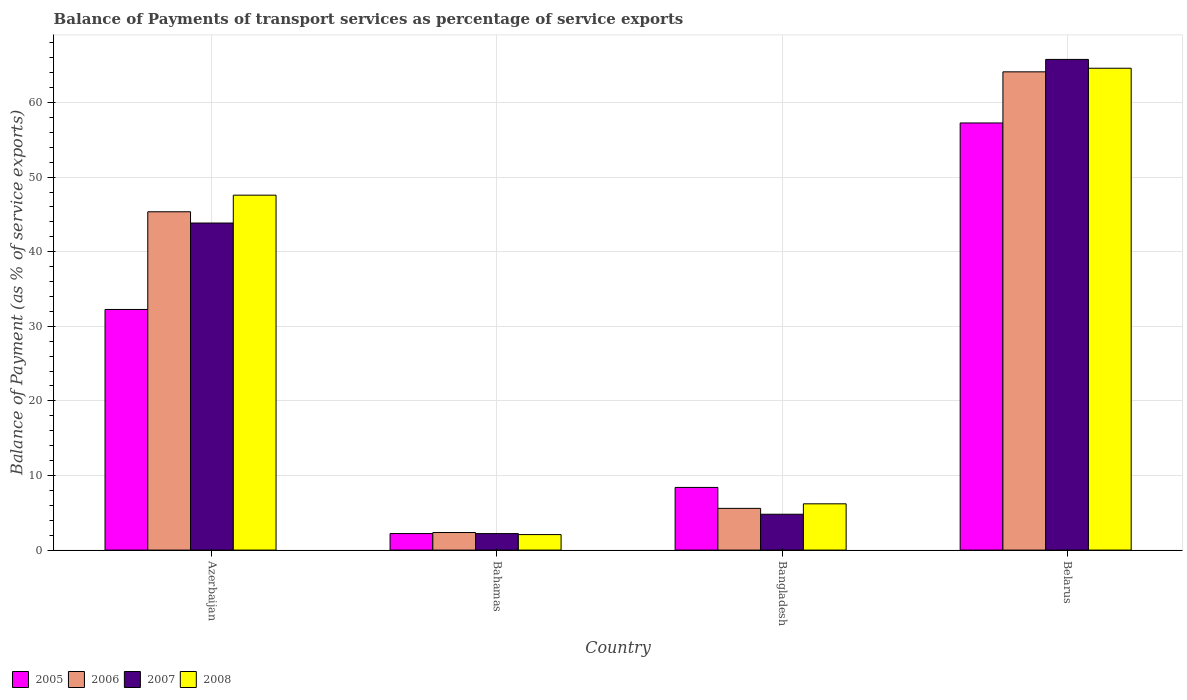How many groups of bars are there?
Offer a terse response. 4. Are the number of bars on each tick of the X-axis equal?
Make the answer very short. Yes. What is the label of the 4th group of bars from the left?
Offer a terse response. Belarus. What is the balance of payments of transport services in 2007 in Bahamas?
Provide a succinct answer. 2.21. Across all countries, what is the maximum balance of payments of transport services in 2006?
Your answer should be very brief. 64.11. Across all countries, what is the minimum balance of payments of transport services in 2008?
Your answer should be compact. 2.08. In which country was the balance of payments of transport services in 2008 maximum?
Offer a terse response. Belarus. In which country was the balance of payments of transport services in 2008 minimum?
Make the answer very short. Bahamas. What is the total balance of payments of transport services in 2005 in the graph?
Give a very brief answer. 100.14. What is the difference between the balance of payments of transport services in 2008 in Azerbaijan and that in Bangladesh?
Provide a succinct answer. 41.38. What is the difference between the balance of payments of transport services in 2008 in Belarus and the balance of payments of transport services in 2006 in Bahamas?
Offer a very short reply. 62.24. What is the average balance of payments of transport services in 2008 per country?
Make the answer very short. 30.12. What is the difference between the balance of payments of transport services of/in 2006 and balance of payments of transport services of/in 2007 in Bangladesh?
Provide a short and direct response. 0.79. In how many countries, is the balance of payments of transport services in 2007 greater than 22 %?
Make the answer very short. 2. What is the ratio of the balance of payments of transport services in 2008 in Azerbaijan to that in Belarus?
Provide a succinct answer. 0.74. Is the balance of payments of transport services in 2008 in Bahamas less than that in Belarus?
Give a very brief answer. Yes. What is the difference between the highest and the second highest balance of payments of transport services in 2005?
Provide a short and direct response. -25. What is the difference between the highest and the lowest balance of payments of transport services in 2007?
Make the answer very short. 63.57. Is it the case that in every country, the sum of the balance of payments of transport services in 2005 and balance of payments of transport services in 2006 is greater than the sum of balance of payments of transport services in 2008 and balance of payments of transport services in 2007?
Provide a succinct answer. No. Is it the case that in every country, the sum of the balance of payments of transport services in 2007 and balance of payments of transport services in 2008 is greater than the balance of payments of transport services in 2005?
Your answer should be very brief. Yes. How many bars are there?
Provide a short and direct response. 16. How many countries are there in the graph?
Your answer should be very brief. 4. What is the difference between two consecutive major ticks on the Y-axis?
Offer a very short reply. 10. Are the values on the major ticks of Y-axis written in scientific E-notation?
Provide a succinct answer. No. Does the graph contain any zero values?
Keep it short and to the point. No. Does the graph contain grids?
Ensure brevity in your answer.  Yes. Where does the legend appear in the graph?
Offer a terse response. Bottom left. How many legend labels are there?
Your answer should be compact. 4. What is the title of the graph?
Provide a succinct answer. Balance of Payments of transport services as percentage of service exports. What is the label or title of the Y-axis?
Offer a terse response. Balance of Payment (as % of service exports). What is the Balance of Payment (as % of service exports) of 2005 in Azerbaijan?
Offer a terse response. 32.26. What is the Balance of Payment (as % of service exports) of 2006 in Azerbaijan?
Keep it short and to the point. 45.35. What is the Balance of Payment (as % of service exports) of 2007 in Azerbaijan?
Provide a short and direct response. 43.85. What is the Balance of Payment (as % of service exports) in 2008 in Azerbaijan?
Provide a succinct answer. 47.58. What is the Balance of Payment (as % of service exports) of 2005 in Bahamas?
Your response must be concise. 2.22. What is the Balance of Payment (as % of service exports) of 2006 in Bahamas?
Offer a very short reply. 2.36. What is the Balance of Payment (as % of service exports) of 2007 in Bahamas?
Ensure brevity in your answer.  2.21. What is the Balance of Payment (as % of service exports) of 2008 in Bahamas?
Provide a succinct answer. 2.08. What is the Balance of Payment (as % of service exports) of 2005 in Bangladesh?
Ensure brevity in your answer.  8.4. What is the Balance of Payment (as % of service exports) in 2006 in Bangladesh?
Offer a terse response. 5.6. What is the Balance of Payment (as % of service exports) in 2007 in Bangladesh?
Keep it short and to the point. 4.81. What is the Balance of Payment (as % of service exports) in 2008 in Bangladesh?
Provide a short and direct response. 6.21. What is the Balance of Payment (as % of service exports) in 2005 in Belarus?
Your answer should be compact. 57.26. What is the Balance of Payment (as % of service exports) in 2006 in Belarus?
Keep it short and to the point. 64.11. What is the Balance of Payment (as % of service exports) in 2007 in Belarus?
Provide a succinct answer. 65.78. What is the Balance of Payment (as % of service exports) of 2008 in Belarus?
Offer a very short reply. 64.6. Across all countries, what is the maximum Balance of Payment (as % of service exports) of 2005?
Keep it short and to the point. 57.26. Across all countries, what is the maximum Balance of Payment (as % of service exports) of 2006?
Keep it short and to the point. 64.11. Across all countries, what is the maximum Balance of Payment (as % of service exports) of 2007?
Offer a terse response. 65.78. Across all countries, what is the maximum Balance of Payment (as % of service exports) in 2008?
Ensure brevity in your answer.  64.6. Across all countries, what is the minimum Balance of Payment (as % of service exports) of 2005?
Your answer should be very brief. 2.22. Across all countries, what is the minimum Balance of Payment (as % of service exports) of 2006?
Give a very brief answer. 2.36. Across all countries, what is the minimum Balance of Payment (as % of service exports) in 2007?
Offer a terse response. 2.21. Across all countries, what is the minimum Balance of Payment (as % of service exports) of 2008?
Give a very brief answer. 2.08. What is the total Balance of Payment (as % of service exports) of 2005 in the graph?
Offer a terse response. 100.14. What is the total Balance of Payment (as % of service exports) in 2006 in the graph?
Your answer should be very brief. 117.42. What is the total Balance of Payment (as % of service exports) of 2007 in the graph?
Offer a terse response. 116.65. What is the total Balance of Payment (as % of service exports) of 2008 in the graph?
Make the answer very short. 120.46. What is the difference between the Balance of Payment (as % of service exports) in 2005 in Azerbaijan and that in Bahamas?
Provide a succinct answer. 30.04. What is the difference between the Balance of Payment (as % of service exports) in 2006 in Azerbaijan and that in Bahamas?
Make the answer very short. 43. What is the difference between the Balance of Payment (as % of service exports) in 2007 in Azerbaijan and that in Bahamas?
Your answer should be compact. 41.63. What is the difference between the Balance of Payment (as % of service exports) in 2008 in Azerbaijan and that in Bahamas?
Your answer should be compact. 45.5. What is the difference between the Balance of Payment (as % of service exports) of 2005 in Azerbaijan and that in Bangladesh?
Keep it short and to the point. 23.86. What is the difference between the Balance of Payment (as % of service exports) in 2006 in Azerbaijan and that in Bangladesh?
Offer a terse response. 39.76. What is the difference between the Balance of Payment (as % of service exports) of 2007 in Azerbaijan and that in Bangladesh?
Give a very brief answer. 39.04. What is the difference between the Balance of Payment (as % of service exports) in 2008 in Azerbaijan and that in Bangladesh?
Give a very brief answer. 41.38. What is the difference between the Balance of Payment (as % of service exports) of 2005 in Azerbaijan and that in Belarus?
Give a very brief answer. -25. What is the difference between the Balance of Payment (as % of service exports) in 2006 in Azerbaijan and that in Belarus?
Ensure brevity in your answer.  -18.76. What is the difference between the Balance of Payment (as % of service exports) of 2007 in Azerbaijan and that in Belarus?
Make the answer very short. -21.93. What is the difference between the Balance of Payment (as % of service exports) in 2008 in Azerbaijan and that in Belarus?
Provide a short and direct response. -17.01. What is the difference between the Balance of Payment (as % of service exports) of 2005 in Bahamas and that in Bangladesh?
Your answer should be very brief. -6.18. What is the difference between the Balance of Payment (as % of service exports) of 2006 in Bahamas and that in Bangladesh?
Your answer should be compact. -3.24. What is the difference between the Balance of Payment (as % of service exports) of 2007 in Bahamas and that in Bangladesh?
Your answer should be very brief. -2.59. What is the difference between the Balance of Payment (as % of service exports) of 2008 in Bahamas and that in Bangladesh?
Keep it short and to the point. -4.12. What is the difference between the Balance of Payment (as % of service exports) of 2005 in Bahamas and that in Belarus?
Offer a terse response. -55.04. What is the difference between the Balance of Payment (as % of service exports) of 2006 in Bahamas and that in Belarus?
Provide a succinct answer. -61.76. What is the difference between the Balance of Payment (as % of service exports) of 2007 in Bahamas and that in Belarus?
Your answer should be compact. -63.57. What is the difference between the Balance of Payment (as % of service exports) in 2008 in Bahamas and that in Belarus?
Ensure brevity in your answer.  -62.51. What is the difference between the Balance of Payment (as % of service exports) in 2005 in Bangladesh and that in Belarus?
Provide a succinct answer. -48.86. What is the difference between the Balance of Payment (as % of service exports) in 2006 in Bangladesh and that in Belarus?
Provide a succinct answer. -58.52. What is the difference between the Balance of Payment (as % of service exports) of 2007 in Bangladesh and that in Belarus?
Ensure brevity in your answer.  -60.97. What is the difference between the Balance of Payment (as % of service exports) in 2008 in Bangladesh and that in Belarus?
Provide a succinct answer. -58.39. What is the difference between the Balance of Payment (as % of service exports) in 2005 in Azerbaijan and the Balance of Payment (as % of service exports) in 2006 in Bahamas?
Your response must be concise. 29.9. What is the difference between the Balance of Payment (as % of service exports) of 2005 in Azerbaijan and the Balance of Payment (as % of service exports) of 2007 in Bahamas?
Offer a terse response. 30.05. What is the difference between the Balance of Payment (as % of service exports) of 2005 in Azerbaijan and the Balance of Payment (as % of service exports) of 2008 in Bahamas?
Offer a very short reply. 30.18. What is the difference between the Balance of Payment (as % of service exports) of 2006 in Azerbaijan and the Balance of Payment (as % of service exports) of 2007 in Bahamas?
Your answer should be very brief. 43.14. What is the difference between the Balance of Payment (as % of service exports) in 2006 in Azerbaijan and the Balance of Payment (as % of service exports) in 2008 in Bahamas?
Give a very brief answer. 43.27. What is the difference between the Balance of Payment (as % of service exports) in 2007 in Azerbaijan and the Balance of Payment (as % of service exports) in 2008 in Bahamas?
Provide a succinct answer. 41.77. What is the difference between the Balance of Payment (as % of service exports) of 2005 in Azerbaijan and the Balance of Payment (as % of service exports) of 2006 in Bangladesh?
Your answer should be very brief. 26.66. What is the difference between the Balance of Payment (as % of service exports) of 2005 in Azerbaijan and the Balance of Payment (as % of service exports) of 2007 in Bangladesh?
Make the answer very short. 27.45. What is the difference between the Balance of Payment (as % of service exports) of 2005 in Azerbaijan and the Balance of Payment (as % of service exports) of 2008 in Bangladesh?
Give a very brief answer. 26.06. What is the difference between the Balance of Payment (as % of service exports) of 2006 in Azerbaijan and the Balance of Payment (as % of service exports) of 2007 in Bangladesh?
Provide a short and direct response. 40.55. What is the difference between the Balance of Payment (as % of service exports) in 2006 in Azerbaijan and the Balance of Payment (as % of service exports) in 2008 in Bangladesh?
Your response must be concise. 39.15. What is the difference between the Balance of Payment (as % of service exports) in 2007 in Azerbaijan and the Balance of Payment (as % of service exports) in 2008 in Bangladesh?
Your response must be concise. 37.64. What is the difference between the Balance of Payment (as % of service exports) in 2005 in Azerbaijan and the Balance of Payment (as % of service exports) in 2006 in Belarus?
Your response must be concise. -31.85. What is the difference between the Balance of Payment (as % of service exports) of 2005 in Azerbaijan and the Balance of Payment (as % of service exports) of 2007 in Belarus?
Your response must be concise. -33.52. What is the difference between the Balance of Payment (as % of service exports) in 2005 in Azerbaijan and the Balance of Payment (as % of service exports) in 2008 in Belarus?
Offer a terse response. -32.34. What is the difference between the Balance of Payment (as % of service exports) of 2006 in Azerbaijan and the Balance of Payment (as % of service exports) of 2007 in Belarus?
Provide a short and direct response. -20.43. What is the difference between the Balance of Payment (as % of service exports) in 2006 in Azerbaijan and the Balance of Payment (as % of service exports) in 2008 in Belarus?
Your response must be concise. -19.24. What is the difference between the Balance of Payment (as % of service exports) of 2007 in Azerbaijan and the Balance of Payment (as % of service exports) of 2008 in Belarus?
Provide a succinct answer. -20.75. What is the difference between the Balance of Payment (as % of service exports) in 2005 in Bahamas and the Balance of Payment (as % of service exports) in 2006 in Bangladesh?
Your answer should be compact. -3.38. What is the difference between the Balance of Payment (as % of service exports) of 2005 in Bahamas and the Balance of Payment (as % of service exports) of 2007 in Bangladesh?
Give a very brief answer. -2.59. What is the difference between the Balance of Payment (as % of service exports) in 2005 in Bahamas and the Balance of Payment (as % of service exports) in 2008 in Bangladesh?
Ensure brevity in your answer.  -3.99. What is the difference between the Balance of Payment (as % of service exports) in 2006 in Bahamas and the Balance of Payment (as % of service exports) in 2007 in Bangladesh?
Offer a terse response. -2.45. What is the difference between the Balance of Payment (as % of service exports) of 2006 in Bahamas and the Balance of Payment (as % of service exports) of 2008 in Bangladesh?
Your answer should be compact. -3.85. What is the difference between the Balance of Payment (as % of service exports) in 2007 in Bahamas and the Balance of Payment (as % of service exports) in 2008 in Bangladesh?
Provide a short and direct response. -3.99. What is the difference between the Balance of Payment (as % of service exports) of 2005 in Bahamas and the Balance of Payment (as % of service exports) of 2006 in Belarus?
Offer a very short reply. -61.9. What is the difference between the Balance of Payment (as % of service exports) of 2005 in Bahamas and the Balance of Payment (as % of service exports) of 2007 in Belarus?
Give a very brief answer. -63.56. What is the difference between the Balance of Payment (as % of service exports) in 2005 in Bahamas and the Balance of Payment (as % of service exports) in 2008 in Belarus?
Keep it short and to the point. -62.38. What is the difference between the Balance of Payment (as % of service exports) in 2006 in Bahamas and the Balance of Payment (as % of service exports) in 2007 in Belarus?
Your response must be concise. -63.42. What is the difference between the Balance of Payment (as % of service exports) in 2006 in Bahamas and the Balance of Payment (as % of service exports) in 2008 in Belarus?
Make the answer very short. -62.24. What is the difference between the Balance of Payment (as % of service exports) of 2007 in Bahamas and the Balance of Payment (as % of service exports) of 2008 in Belarus?
Ensure brevity in your answer.  -62.38. What is the difference between the Balance of Payment (as % of service exports) in 2005 in Bangladesh and the Balance of Payment (as % of service exports) in 2006 in Belarus?
Keep it short and to the point. -55.71. What is the difference between the Balance of Payment (as % of service exports) of 2005 in Bangladesh and the Balance of Payment (as % of service exports) of 2007 in Belarus?
Give a very brief answer. -57.38. What is the difference between the Balance of Payment (as % of service exports) of 2005 in Bangladesh and the Balance of Payment (as % of service exports) of 2008 in Belarus?
Keep it short and to the point. -56.19. What is the difference between the Balance of Payment (as % of service exports) in 2006 in Bangladesh and the Balance of Payment (as % of service exports) in 2007 in Belarus?
Keep it short and to the point. -60.18. What is the difference between the Balance of Payment (as % of service exports) in 2006 in Bangladesh and the Balance of Payment (as % of service exports) in 2008 in Belarus?
Keep it short and to the point. -59. What is the difference between the Balance of Payment (as % of service exports) in 2007 in Bangladesh and the Balance of Payment (as % of service exports) in 2008 in Belarus?
Give a very brief answer. -59.79. What is the average Balance of Payment (as % of service exports) in 2005 per country?
Offer a very short reply. 25.03. What is the average Balance of Payment (as % of service exports) in 2006 per country?
Offer a terse response. 29.36. What is the average Balance of Payment (as % of service exports) of 2007 per country?
Ensure brevity in your answer.  29.16. What is the average Balance of Payment (as % of service exports) in 2008 per country?
Offer a very short reply. 30.12. What is the difference between the Balance of Payment (as % of service exports) in 2005 and Balance of Payment (as % of service exports) in 2006 in Azerbaijan?
Ensure brevity in your answer.  -13.09. What is the difference between the Balance of Payment (as % of service exports) of 2005 and Balance of Payment (as % of service exports) of 2007 in Azerbaijan?
Your response must be concise. -11.59. What is the difference between the Balance of Payment (as % of service exports) in 2005 and Balance of Payment (as % of service exports) in 2008 in Azerbaijan?
Your answer should be very brief. -15.32. What is the difference between the Balance of Payment (as % of service exports) of 2006 and Balance of Payment (as % of service exports) of 2007 in Azerbaijan?
Your response must be concise. 1.51. What is the difference between the Balance of Payment (as % of service exports) of 2006 and Balance of Payment (as % of service exports) of 2008 in Azerbaijan?
Offer a very short reply. -2.23. What is the difference between the Balance of Payment (as % of service exports) in 2007 and Balance of Payment (as % of service exports) in 2008 in Azerbaijan?
Keep it short and to the point. -3.73. What is the difference between the Balance of Payment (as % of service exports) in 2005 and Balance of Payment (as % of service exports) in 2006 in Bahamas?
Your response must be concise. -0.14. What is the difference between the Balance of Payment (as % of service exports) in 2005 and Balance of Payment (as % of service exports) in 2007 in Bahamas?
Give a very brief answer. 0. What is the difference between the Balance of Payment (as % of service exports) in 2005 and Balance of Payment (as % of service exports) in 2008 in Bahamas?
Make the answer very short. 0.14. What is the difference between the Balance of Payment (as % of service exports) of 2006 and Balance of Payment (as % of service exports) of 2007 in Bahamas?
Ensure brevity in your answer.  0.14. What is the difference between the Balance of Payment (as % of service exports) in 2006 and Balance of Payment (as % of service exports) in 2008 in Bahamas?
Your response must be concise. 0.28. What is the difference between the Balance of Payment (as % of service exports) in 2007 and Balance of Payment (as % of service exports) in 2008 in Bahamas?
Provide a succinct answer. 0.13. What is the difference between the Balance of Payment (as % of service exports) of 2005 and Balance of Payment (as % of service exports) of 2006 in Bangladesh?
Your response must be concise. 2.81. What is the difference between the Balance of Payment (as % of service exports) in 2005 and Balance of Payment (as % of service exports) in 2007 in Bangladesh?
Make the answer very short. 3.59. What is the difference between the Balance of Payment (as % of service exports) in 2005 and Balance of Payment (as % of service exports) in 2008 in Bangladesh?
Your response must be concise. 2.2. What is the difference between the Balance of Payment (as % of service exports) in 2006 and Balance of Payment (as % of service exports) in 2007 in Bangladesh?
Make the answer very short. 0.79. What is the difference between the Balance of Payment (as % of service exports) in 2006 and Balance of Payment (as % of service exports) in 2008 in Bangladesh?
Make the answer very short. -0.61. What is the difference between the Balance of Payment (as % of service exports) of 2007 and Balance of Payment (as % of service exports) of 2008 in Bangladesh?
Your answer should be compact. -1.4. What is the difference between the Balance of Payment (as % of service exports) of 2005 and Balance of Payment (as % of service exports) of 2006 in Belarus?
Offer a terse response. -6.85. What is the difference between the Balance of Payment (as % of service exports) in 2005 and Balance of Payment (as % of service exports) in 2007 in Belarus?
Your answer should be compact. -8.52. What is the difference between the Balance of Payment (as % of service exports) of 2005 and Balance of Payment (as % of service exports) of 2008 in Belarus?
Your answer should be very brief. -7.34. What is the difference between the Balance of Payment (as % of service exports) in 2006 and Balance of Payment (as % of service exports) in 2007 in Belarus?
Your answer should be compact. -1.67. What is the difference between the Balance of Payment (as % of service exports) of 2006 and Balance of Payment (as % of service exports) of 2008 in Belarus?
Provide a succinct answer. -0.48. What is the difference between the Balance of Payment (as % of service exports) in 2007 and Balance of Payment (as % of service exports) in 2008 in Belarus?
Keep it short and to the point. 1.18. What is the ratio of the Balance of Payment (as % of service exports) in 2005 in Azerbaijan to that in Bahamas?
Provide a short and direct response. 14.56. What is the ratio of the Balance of Payment (as % of service exports) in 2006 in Azerbaijan to that in Bahamas?
Your response must be concise. 19.25. What is the ratio of the Balance of Payment (as % of service exports) in 2007 in Azerbaijan to that in Bahamas?
Ensure brevity in your answer.  19.81. What is the ratio of the Balance of Payment (as % of service exports) of 2008 in Azerbaijan to that in Bahamas?
Your answer should be very brief. 22.87. What is the ratio of the Balance of Payment (as % of service exports) in 2005 in Azerbaijan to that in Bangladesh?
Your answer should be very brief. 3.84. What is the ratio of the Balance of Payment (as % of service exports) in 2006 in Azerbaijan to that in Bangladesh?
Make the answer very short. 8.11. What is the ratio of the Balance of Payment (as % of service exports) of 2007 in Azerbaijan to that in Bangladesh?
Your answer should be very brief. 9.12. What is the ratio of the Balance of Payment (as % of service exports) in 2008 in Azerbaijan to that in Bangladesh?
Your response must be concise. 7.67. What is the ratio of the Balance of Payment (as % of service exports) of 2005 in Azerbaijan to that in Belarus?
Ensure brevity in your answer.  0.56. What is the ratio of the Balance of Payment (as % of service exports) in 2006 in Azerbaijan to that in Belarus?
Offer a terse response. 0.71. What is the ratio of the Balance of Payment (as % of service exports) in 2007 in Azerbaijan to that in Belarus?
Your answer should be compact. 0.67. What is the ratio of the Balance of Payment (as % of service exports) of 2008 in Azerbaijan to that in Belarus?
Make the answer very short. 0.74. What is the ratio of the Balance of Payment (as % of service exports) of 2005 in Bahamas to that in Bangladesh?
Make the answer very short. 0.26. What is the ratio of the Balance of Payment (as % of service exports) of 2006 in Bahamas to that in Bangladesh?
Provide a short and direct response. 0.42. What is the ratio of the Balance of Payment (as % of service exports) of 2007 in Bahamas to that in Bangladesh?
Offer a very short reply. 0.46. What is the ratio of the Balance of Payment (as % of service exports) of 2008 in Bahamas to that in Bangladesh?
Offer a very short reply. 0.34. What is the ratio of the Balance of Payment (as % of service exports) of 2005 in Bahamas to that in Belarus?
Keep it short and to the point. 0.04. What is the ratio of the Balance of Payment (as % of service exports) in 2006 in Bahamas to that in Belarus?
Make the answer very short. 0.04. What is the ratio of the Balance of Payment (as % of service exports) in 2007 in Bahamas to that in Belarus?
Provide a succinct answer. 0.03. What is the ratio of the Balance of Payment (as % of service exports) of 2008 in Bahamas to that in Belarus?
Your answer should be very brief. 0.03. What is the ratio of the Balance of Payment (as % of service exports) in 2005 in Bangladesh to that in Belarus?
Keep it short and to the point. 0.15. What is the ratio of the Balance of Payment (as % of service exports) in 2006 in Bangladesh to that in Belarus?
Ensure brevity in your answer.  0.09. What is the ratio of the Balance of Payment (as % of service exports) of 2007 in Bangladesh to that in Belarus?
Keep it short and to the point. 0.07. What is the ratio of the Balance of Payment (as % of service exports) in 2008 in Bangladesh to that in Belarus?
Provide a short and direct response. 0.1. What is the difference between the highest and the second highest Balance of Payment (as % of service exports) in 2005?
Your response must be concise. 25. What is the difference between the highest and the second highest Balance of Payment (as % of service exports) in 2006?
Provide a succinct answer. 18.76. What is the difference between the highest and the second highest Balance of Payment (as % of service exports) in 2007?
Your answer should be compact. 21.93. What is the difference between the highest and the second highest Balance of Payment (as % of service exports) of 2008?
Provide a short and direct response. 17.01. What is the difference between the highest and the lowest Balance of Payment (as % of service exports) in 2005?
Give a very brief answer. 55.04. What is the difference between the highest and the lowest Balance of Payment (as % of service exports) of 2006?
Offer a very short reply. 61.76. What is the difference between the highest and the lowest Balance of Payment (as % of service exports) in 2007?
Make the answer very short. 63.57. What is the difference between the highest and the lowest Balance of Payment (as % of service exports) of 2008?
Make the answer very short. 62.51. 